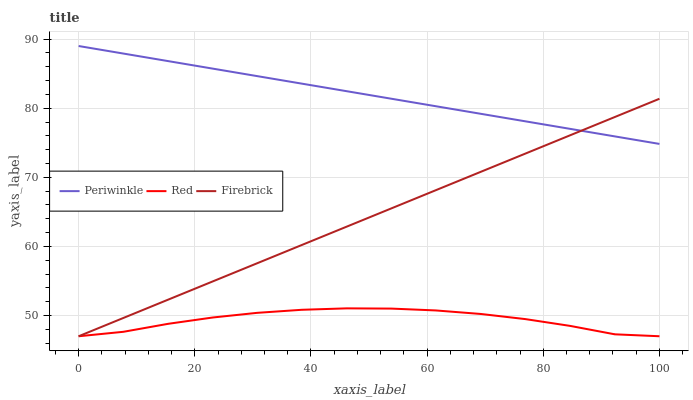Does Red have the minimum area under the curve?
Answer yes or no. Yes. Does Periwinkle have the maximum area under the curve?
Answer yes or no. Yes. Does Periwinkle have the minimum area under the curve?
Answer yes or no. No. Does Red have the maximum area under the curve?
Answer yes or no. No. Is Firebrick the smoothest?
Answer yes or no. Yes. Is Red the roughest?
Answer yes or no. Yes. Is Periwinkle the smoothest?
Answer yes or no. No. Is Periwinkle the roughest?
Answer yes or no. No. Does Firebrick have the lowest value?
Answer yes or no. Yes. Does Periwinkle have the lowest value?
Answer yes or no. No. Does Periwinkle have the highest value?
Answer yes or no. Yes. Does Red have the highest value?
Answer yes or no. No. Is Red less than Periwinkle?
Answer yes or no. Yes. Is Periwinkle greater than Red?
Answer yes or no. Yes. Does Firebrick intersect Red?
Answer yes or no. Yes. Is Firebrick less than Red?
Answer yes or no. No. Is Firebrick greater than Red?
Answer yes or no. No. Does Red intersect Periwinkle?
Answer yes or no. No. 